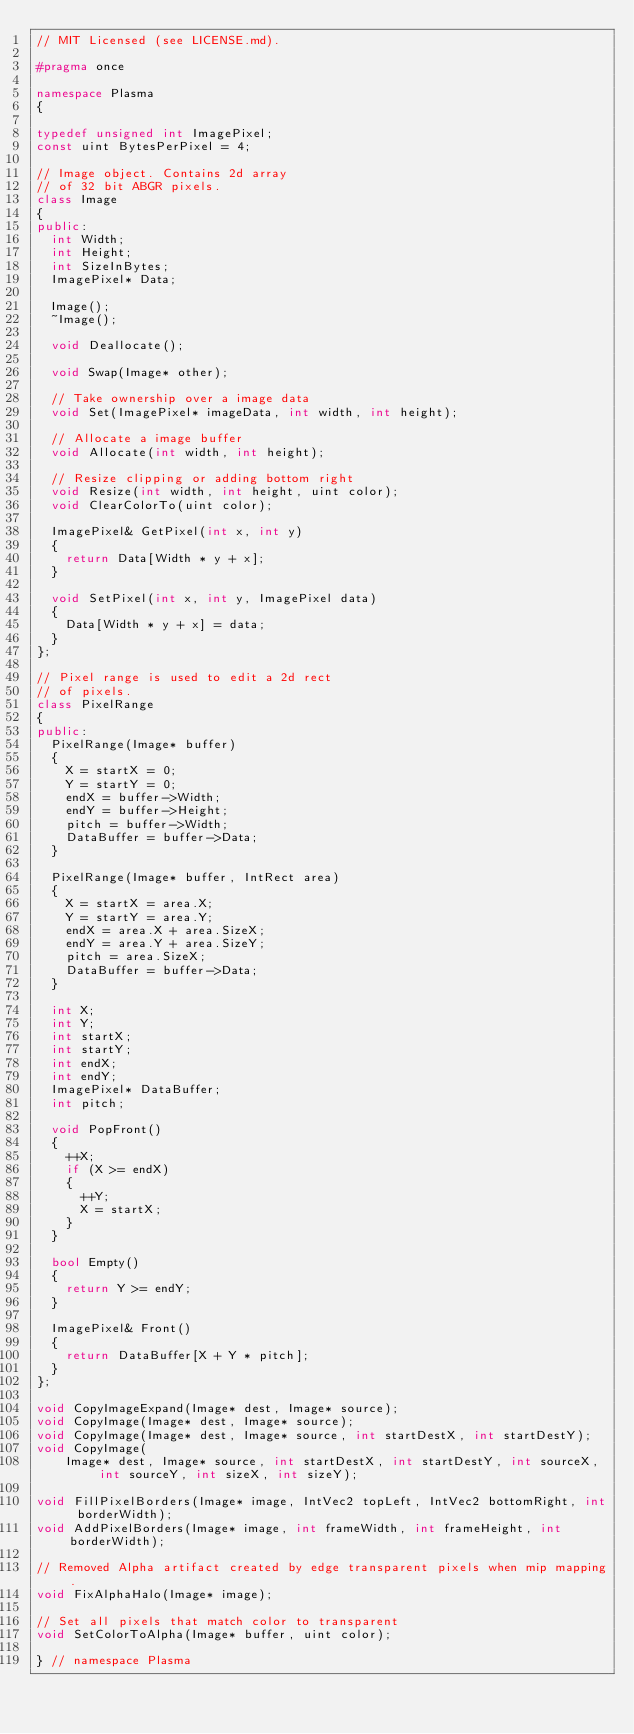<code> <loc_0><loc_0><loc_500><loc_500><_C++_>// MIT Licensed (see LICENSE.md).

#pragma once

namespace Plasma
{

typedef unsigned int ImagePixel;
const uint BytesPerPixel = 4;

// Image object. Contains 2d array
// of 32 bit ABGR pixels.
class Image
{
public:
  int Width;
  int Height;
  int SizeInBytes;
  ImagePixel* Data;

  Image();
  ~Image();

  void Deallocate();

  void Swap(Image* other);

  // Take ownership over a image data
  void Set(ImagePixel* imageData, int width, int height);

  // Allocate a image buffer
  void Allocate(int width, int height);

  // Resize clipping or adding bottom right
  void Resize(int width, int height, uint color);
  void ClearColorTo(uint color);

  ImagePixel& GetPixel(int x, int y)
  {
    return Data[Width * y + x];
  }

  void SetPixel(int x, int y, ImagePixel data)
  {
    Data[Width * y + x] = data;
  }
};

// Pixel range is used to edit a 2d rect
// of pixels.
class PixelRange
{
public:
  PixelRange(Image* buffer)
  {
    X = startX = 0;
    Y = startY = 0;
    endX = buffer->Width;
    endY = buffer->Height;
    pitch = buffer->Width;
    DataBuffer = buffer->Data;
  }

  PixelRange(Image* buffer, IntRect area)
  {
    X = startX = area.X;
    Y = startY = area.Y;
    endX = area.X + area.SizeX;
    endY = area.Y + area.SizeY;
    pitch = area.SizeX;
    DataBuffer = buffer->Data;
  }

  int X;
  int Y;
  int startX;
  int startY;
  int endX;
  int endY;
  ImagePixel* DataBuffer;
  int pitch;

  void PopFront()
  {
    ++X;
    if (X >= endX)
    {
      ++Y;
      X = startX;
    }
  }

  bool Empty()
  {
    return Y >= endY;
  }

  ImagePixel& Front()
  {
    return DataBuffer[X + Y * pitch];
  }
};

void CopyImageExpand(Image* dest, Image* source);
void CopyImage(Image* dest, Image* source);
void CopyImage(Image* dest, Image* source, int startDestX, int startDestY);
void CopyImage(
    Image* dest, Image* source, int startDestX, int startDestY, int sourceX, int sourceY, int sizeX, int sizeY);

void FillPixelBorders(Image* image, IntVec2 topLeft, IntVec2 bottomRight, int borderWidth);
void AddPixelBorders(Image* image, int frameWidth, int frameHeight, int borderWidth);

// Removed Alpha artifact created by edge transparent pixels when mip mapping.
void FixAlphaHalo(Image* image);

// Set all pixels that match color to transparent
void SetColorToAlpha(Image* buffer, uint color);

} // namespace Plasma
</code> 